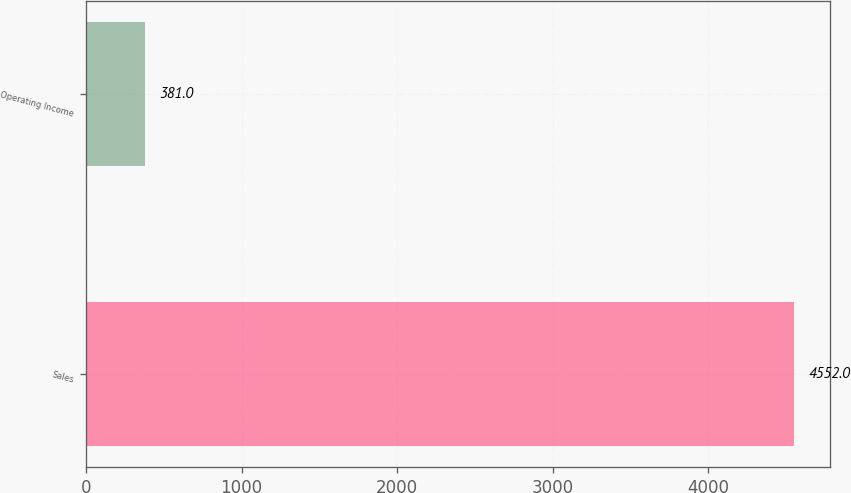<chart> <loc_0><loc_0><loc_500><loc_500><bar_chart><fcel>Sales<fcel>Operating Income<nl><fcel>4552<fcel>381<nl></chart> 